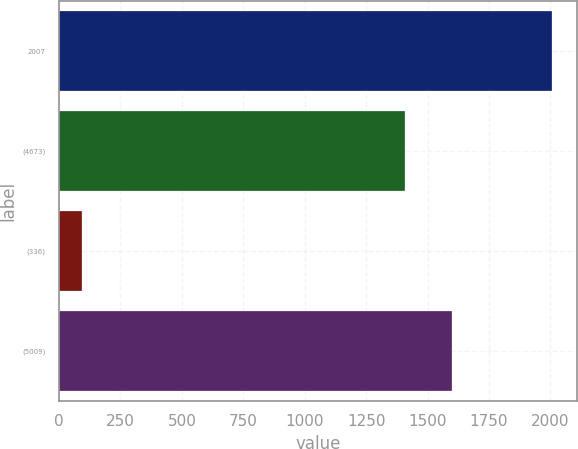<chart> <loc_0><loc_0><loc_500><loc_500><bar_chart><fcel>2007<fcel>(4673)<fcel>(336)<fcel>(5009)<nl><fcel>2006<fcel>1409<fcel>93<fcel>1600.3<nl></chart> 